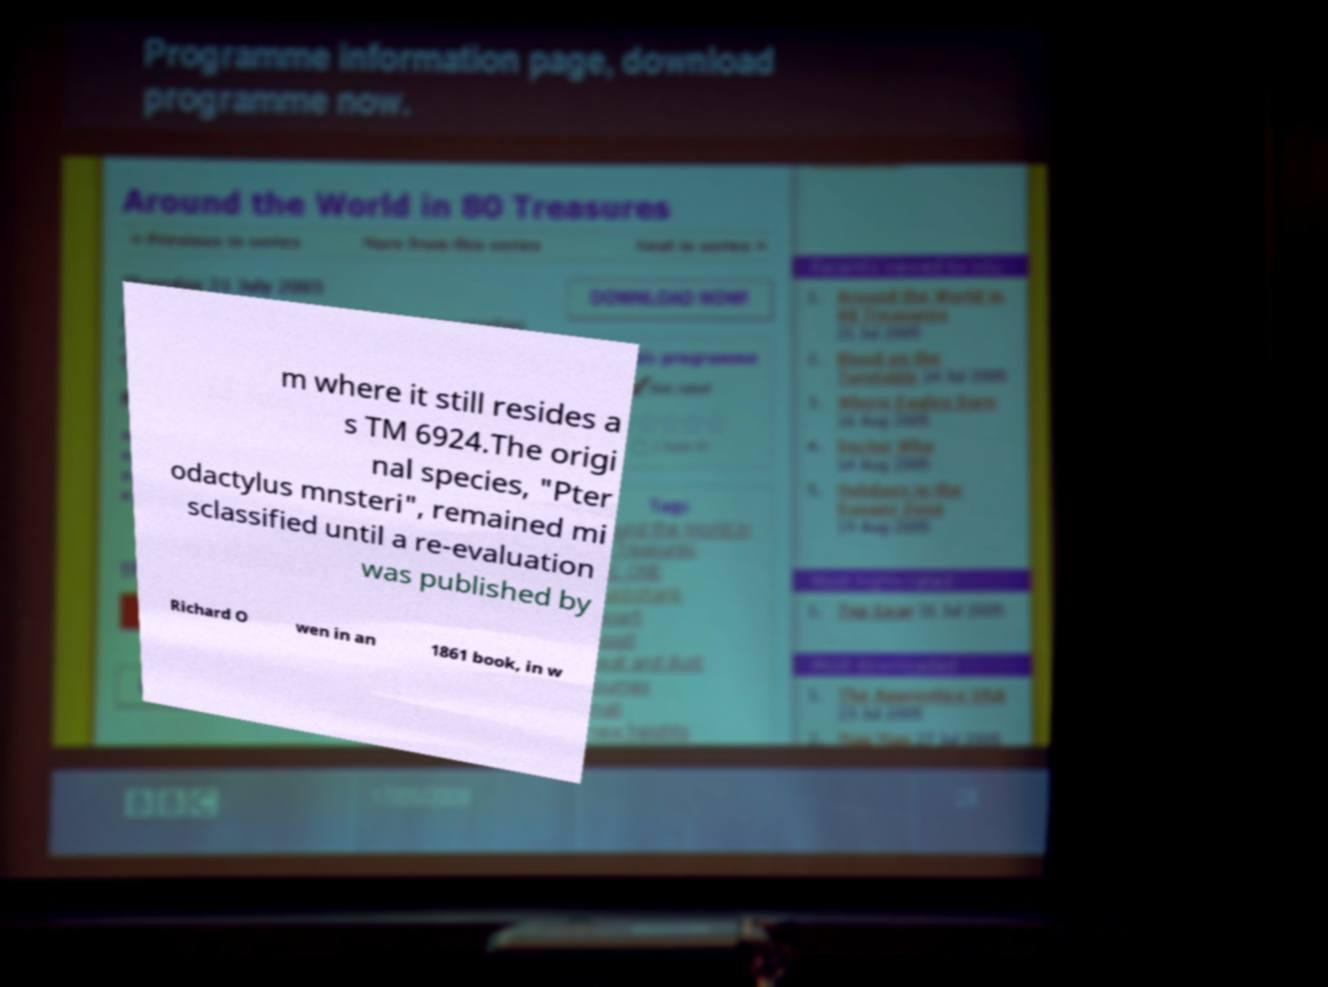For documentation purposes, I need the text within this image transcribed. Could you provide that? m where it still resides a s TM 6924.The origi nal species, "Pter odactylus mnsteri", remained mi sclassified until a re-evaluation was published by Richard O wen in an 1861 book, in w 